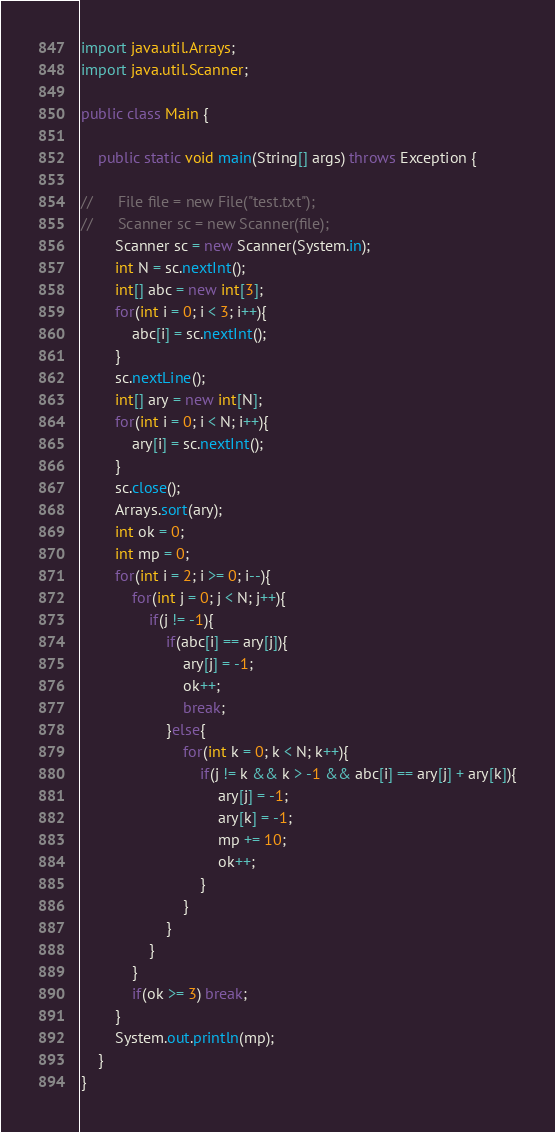<code> <loc_0><loc_0><loc_500><loc_500><_Java_>import java.util.Arrays;
import java.util.Scanner;

public class Main {

    public static void main(String[] args) throws Exception {

//    	File file = new File("test.txt");
//    	Scanner sc = new Scanner(file);
    	Scanner sc = new Scanner(System.in);
    	int N = sc.nextInt();
    	int[] abc = new int[3];
    	for(int i = 0; i < 3; i++){
    		abc[i] = sc.nextInt();
    	}
    	sc.nextLine();
    	int[] ary = new int[N];
    	for(int i = 0; i < N; i++){
    		ary[i] = sc.nextInt();
    	}
    	sc.close();
    	Arrays.sort(ary);
    	int ok = 0;
    	int mp = 0;
    	for(int i = 2; i >= 0; i--){
    		for(int j = 0; j < N; j++){
    			if(j != -1){
    				if(abc[i] == ary[j]){
        				ary[j] = -1;
        				ok++;
        				break;
        			}else{
        				for(int k = 0; k < N; k++){
        					if(j != k && k > -1 && abc[i] == ary[j] + ary[k]){
        						ary[j] = -1;
        						ary[k] = -1;
        						mp += 10;
        						ok++;
        					}
        				}
        			}
    			}
    		}
    		if(ok >= 3) break;
    	}
    	System.out.println(mp);
    }
}</code> 